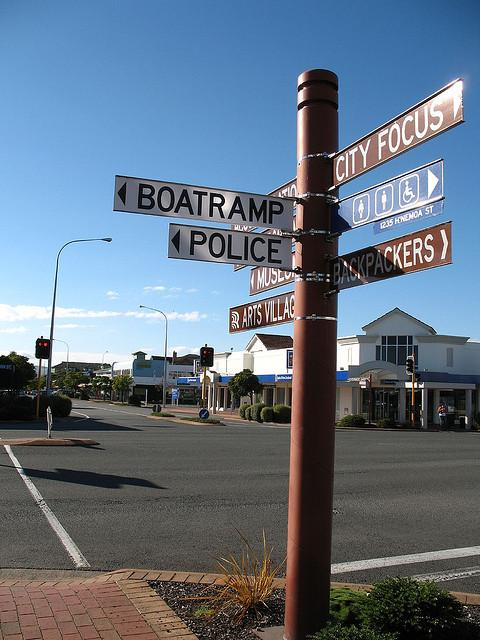What sign should I follow if I have lost my wallet? Please explain your reasoning. police. The sign for the police station is to the left. people who lose wallets may check to see if anyone has turned in a wallet that was found. 